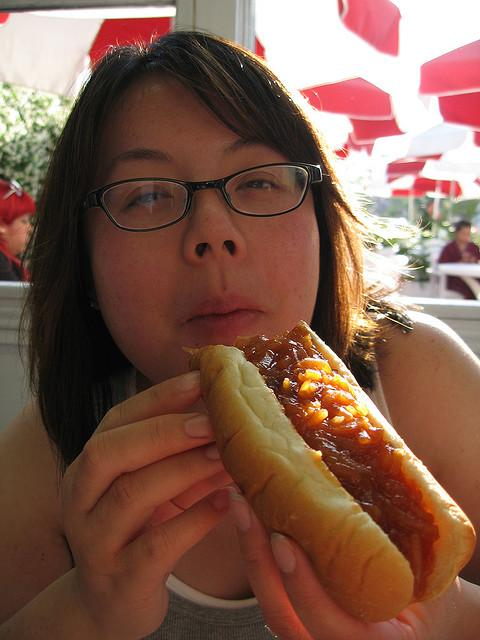In what place was the bread eaten here cooked? Please explain your reasoning. oven. The bread is not cooked in oil, only using heat, so the oven is the best option. 